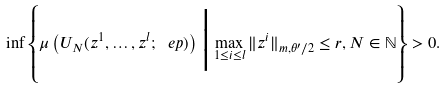Convert formula to latex. <formula><loc_0><loc_0><loc_500><loc_500>\inf \left \{ \mu \left ( U _ { N } ( z ^ { 1 } , \dots , z ^ { l } ; \ e p ) \right ) \Big | \max _ { 1 \leq i \leq l } \| z ^ { i } \| _ { m , \theta ^ { \prime } / 2 } \leq r , N \in { \mathbb { N } } \right \} > 0 .</formula> 